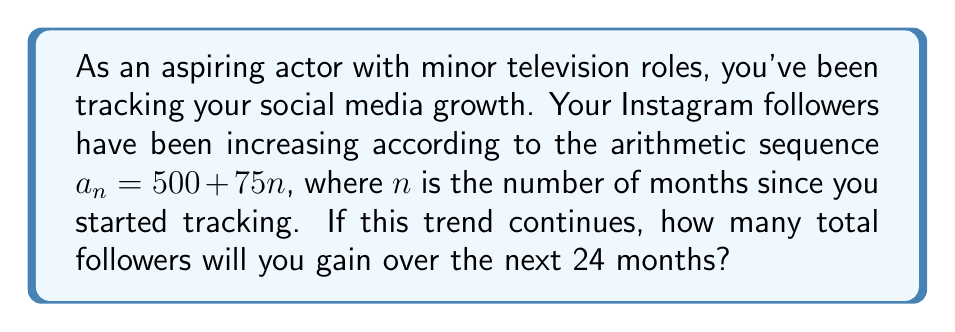Show me your answer to this math problem. Let's approach this step-by-step:

1) The given sequence is arithmetic with $a_1 = 575$ and common difference $d = 75$.

2) We need to find the sum of the next 24 terms of this sequence.

3) For an arithmetic sequence, we can use the formula for the sum of $n$ terms:

   $$S_n = \frac{n}{2}(a_1 + a_n)$$

   where $a_1$ is the first term and $a_n$ is the last term.

4) In our case, $n = 24$, $a_1 = 575$, and we need to find $a_{24}$:

   $a_{24} = a_1 + (n-1)d = 575 + (23)(75) = 2300$

5) Now we can substitute into our sum formula:

   $$S_{24} = \frac{24}{2}(575 + 2300) = 12(2875) = 34,500$$

6) However, this sum includes the initial 500 followers. To find the total gained, we need to subtract 500:

   $34,500 - 500 = 34,000$

Thus, over the next 24 months, you will gain 34,000 new followers.
Answer: 34,000 followers 